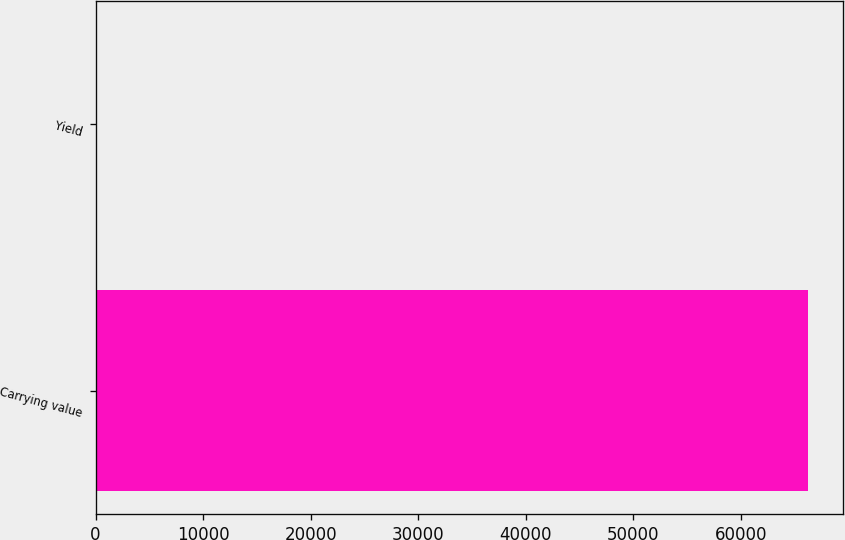Convert chart to OTSL. <chart><loc_0><loc_0><loc_500><loc_500><bar_chart><fcel>Carrying value<fcel>Yield<nl><fcel>66200<fcel>3.82<nl></chart> 